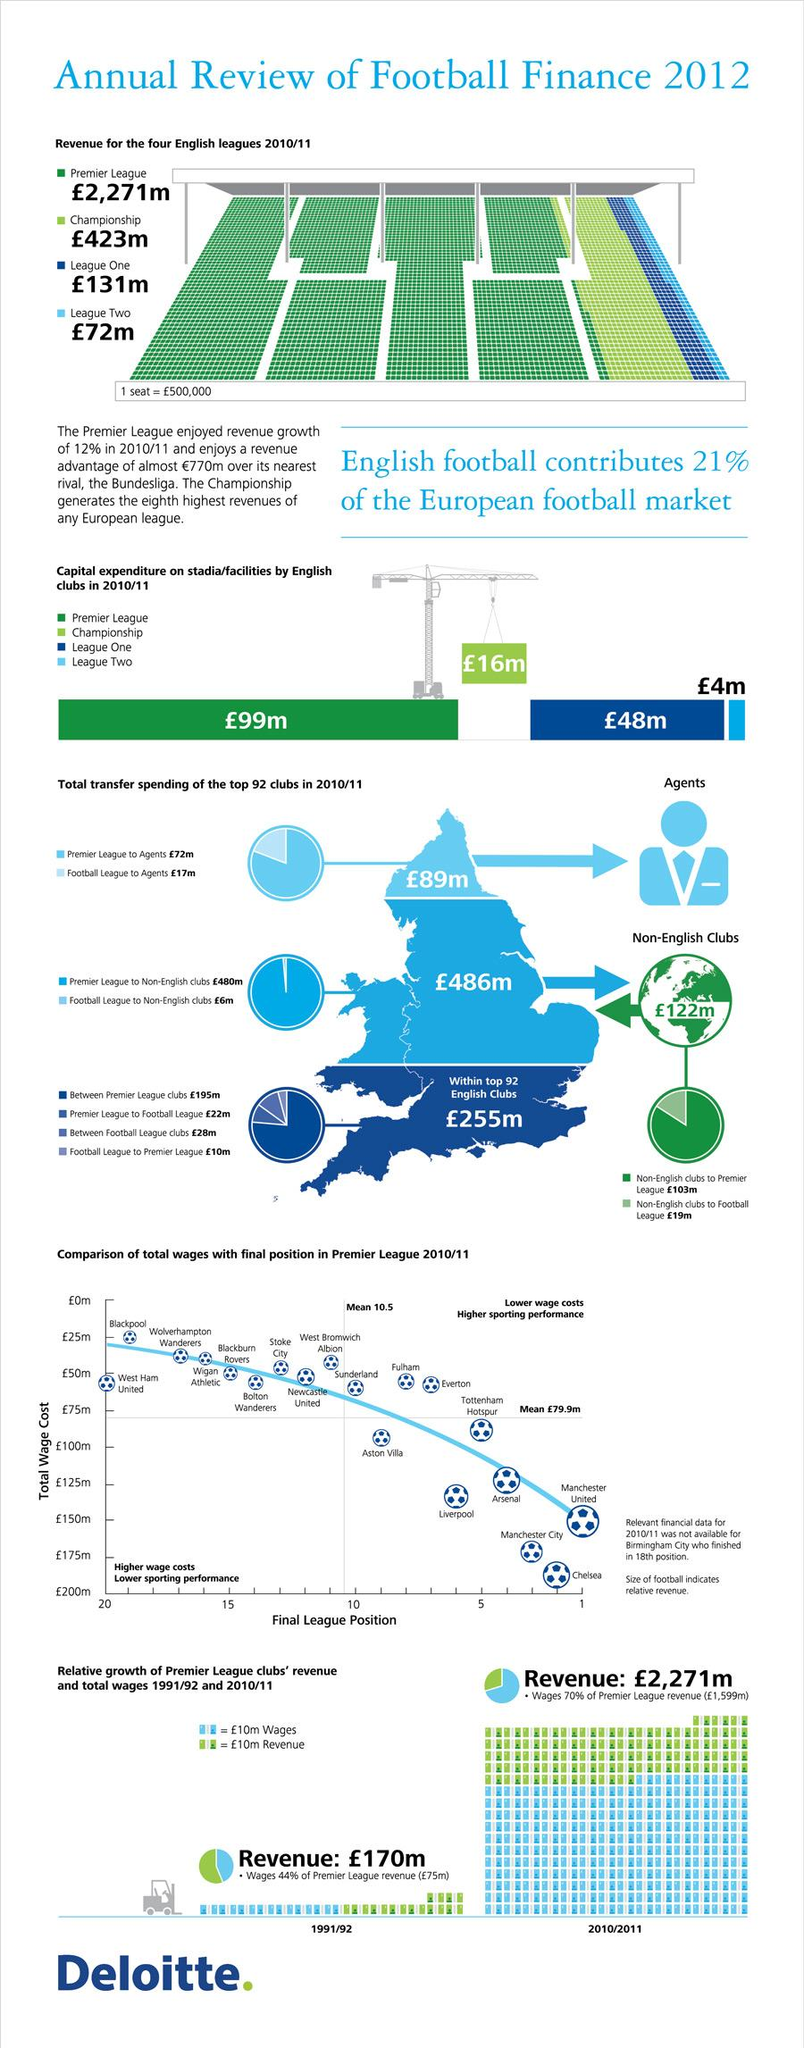Indicate a few pertinent items in this graphic. The difference in transfer spending on non-English clubs in the Premier League and Football League is approximately 474 million pounds. Which team invested the second largest amount of capital on facilities in League One? The amount paid by non-English Premier League clubs is 103 million pounds, 480 million pounds, or 122 million pounds. The total revenue for all four English leagues in 2010/11 was £2,897. The amount written in pounds on the globe is 122 m. 